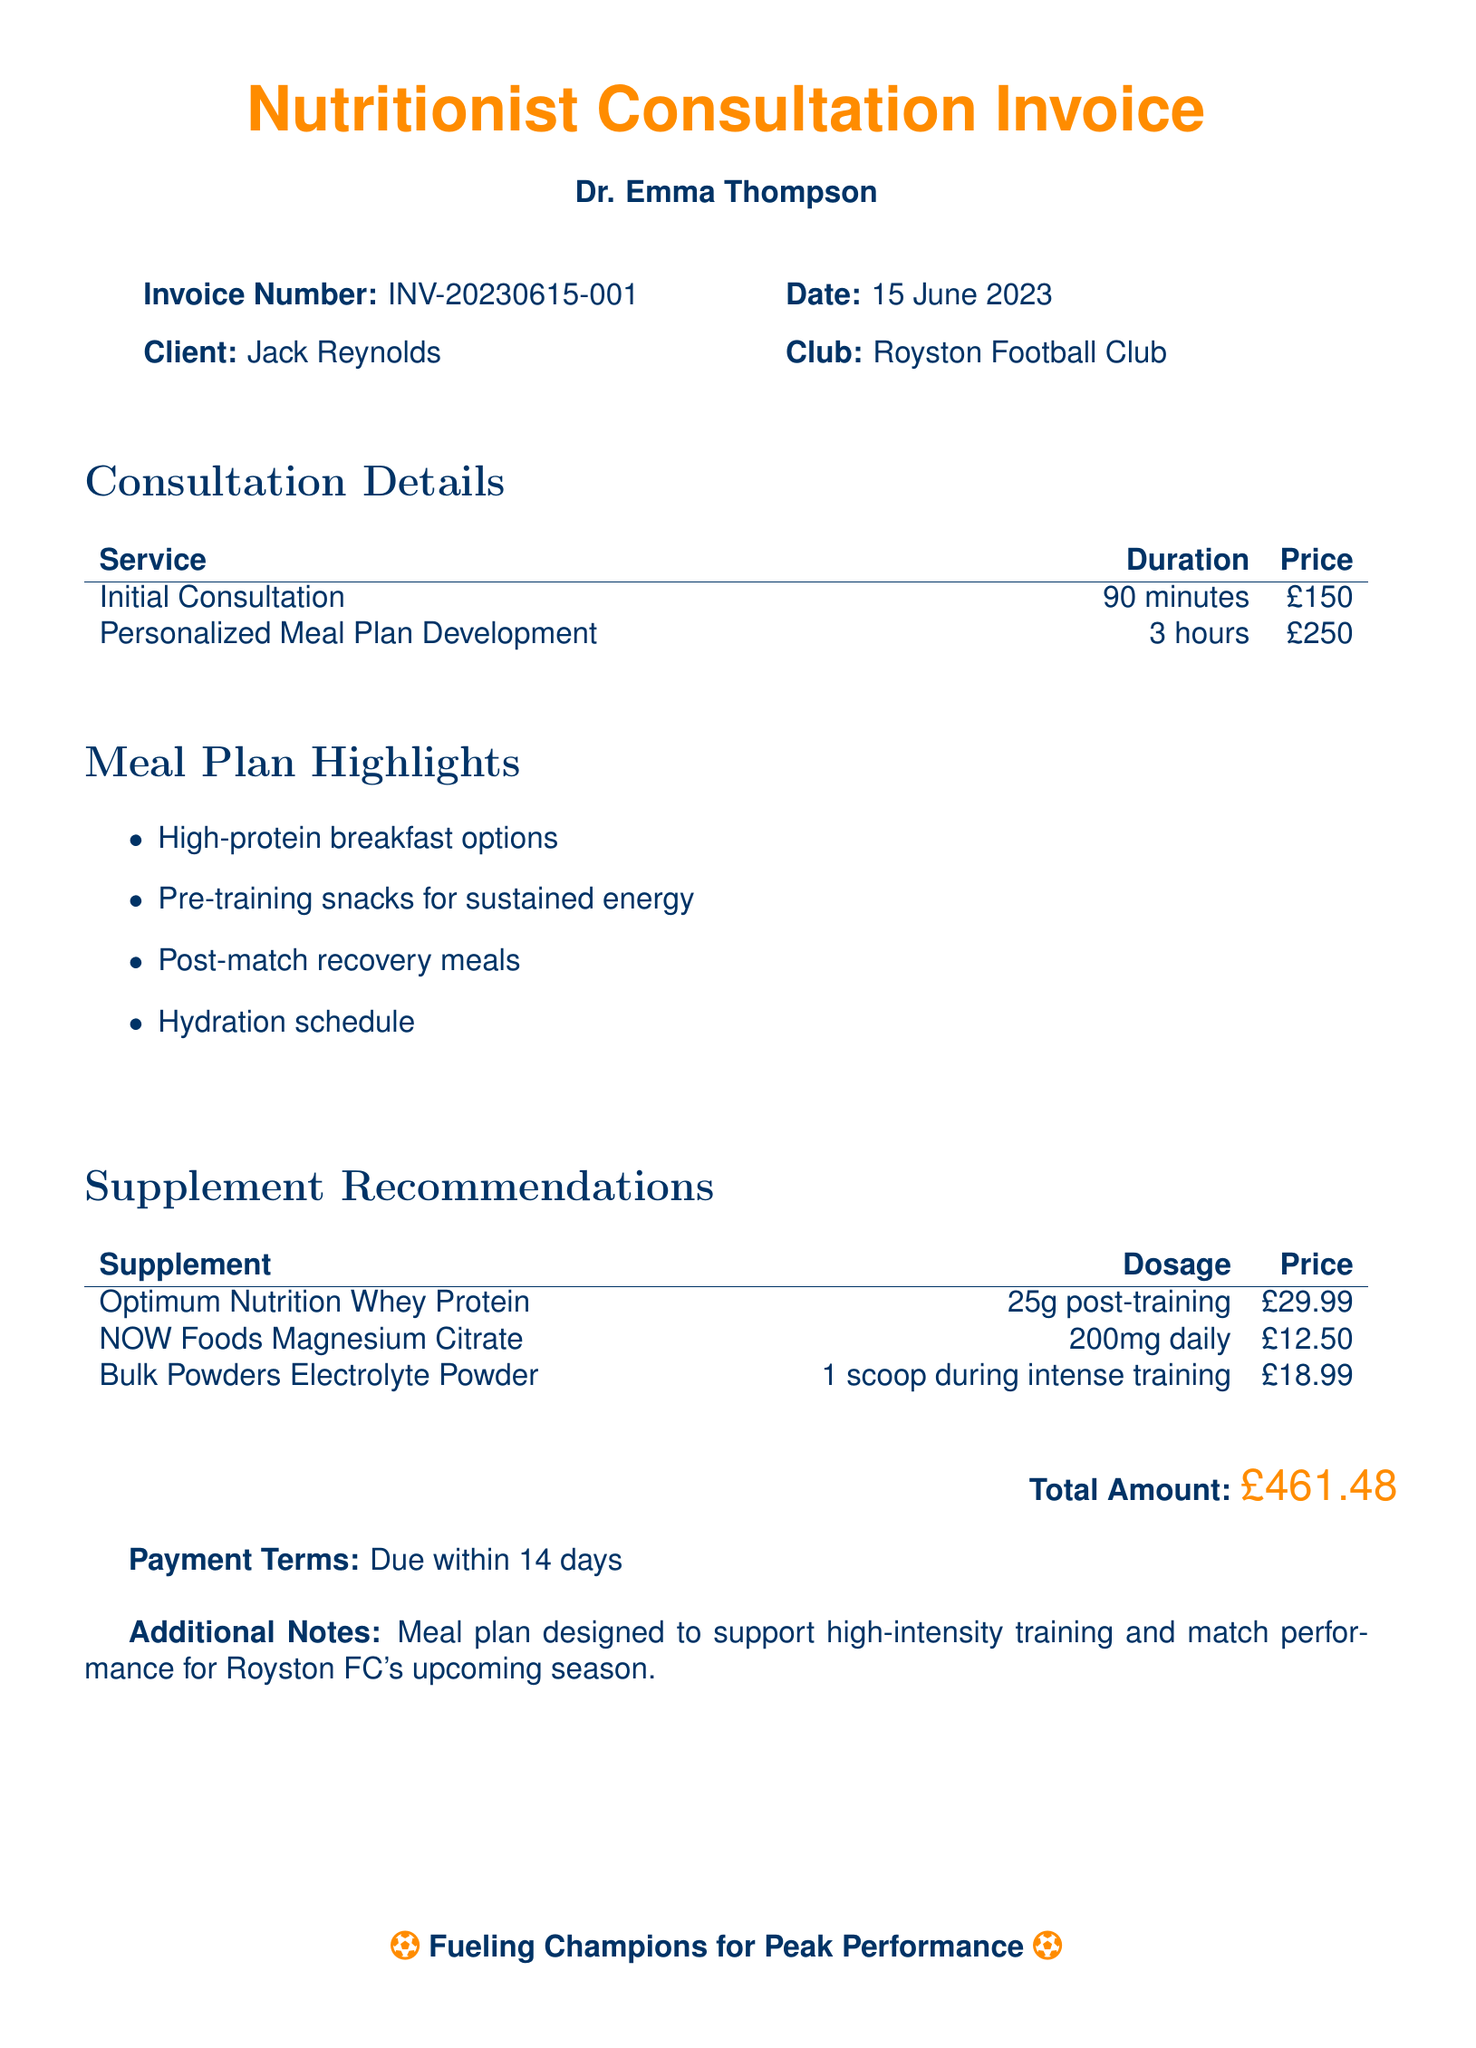What is the invoice number? The invoice number is listed at the top of the document, identifying it uniquely.
Answer: INV-20230615-001 Who is the client? The client's name is mentioned in the client section of the document.
Answer: Jack Reynolds What is the total amount due? The total amount due is displayed prominently towards the end of the invoice.
Answer: £461.48 How long did the consultation last? The duration of the initial consultation is specified in the consultation details section.
Answer: 90 minutes What is one highlight of the personalized meal plan? Highlights are listed in a bullet point format under meal plan highlights.
Answer: High-protein breakfast options What is the dosage of the magnesium citrate supplement? The dosage for the supplement is clearly indicated in the supplement recommendations section.
Answer: 200mg daily What service had the highest price? The services and their prices are listed, allowing comparison of costs.
Answer: Personalized Meal Plan Development What is the payment term indicated in the document? The payment terms are stated at the bottom of the document after the total amount.
Answer: Due within 14 days Which club is associated with the client? The club's name is noted in the client section of the invoice.
Answer: Royston Football Club 